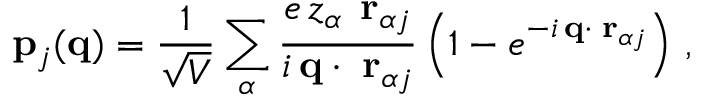Convert formula to latex. <formula><loc_0><loc_0><loc_500><loc_500>{ p } _ { j } ( { q } ) = \frac { 1 } { \sqrt { V } } \sum _ { \alpha } \frac { e \, z _ { \alpha } \, { \delta r } _ { \alpha j } } { i \, { q } \cdot { \delta r } _ { \alpha j } } \left ( 1 - e ^ { - i \, { q } \cdot { \delta r } _ { \alpha j } } \right ) \, ,</formula> 